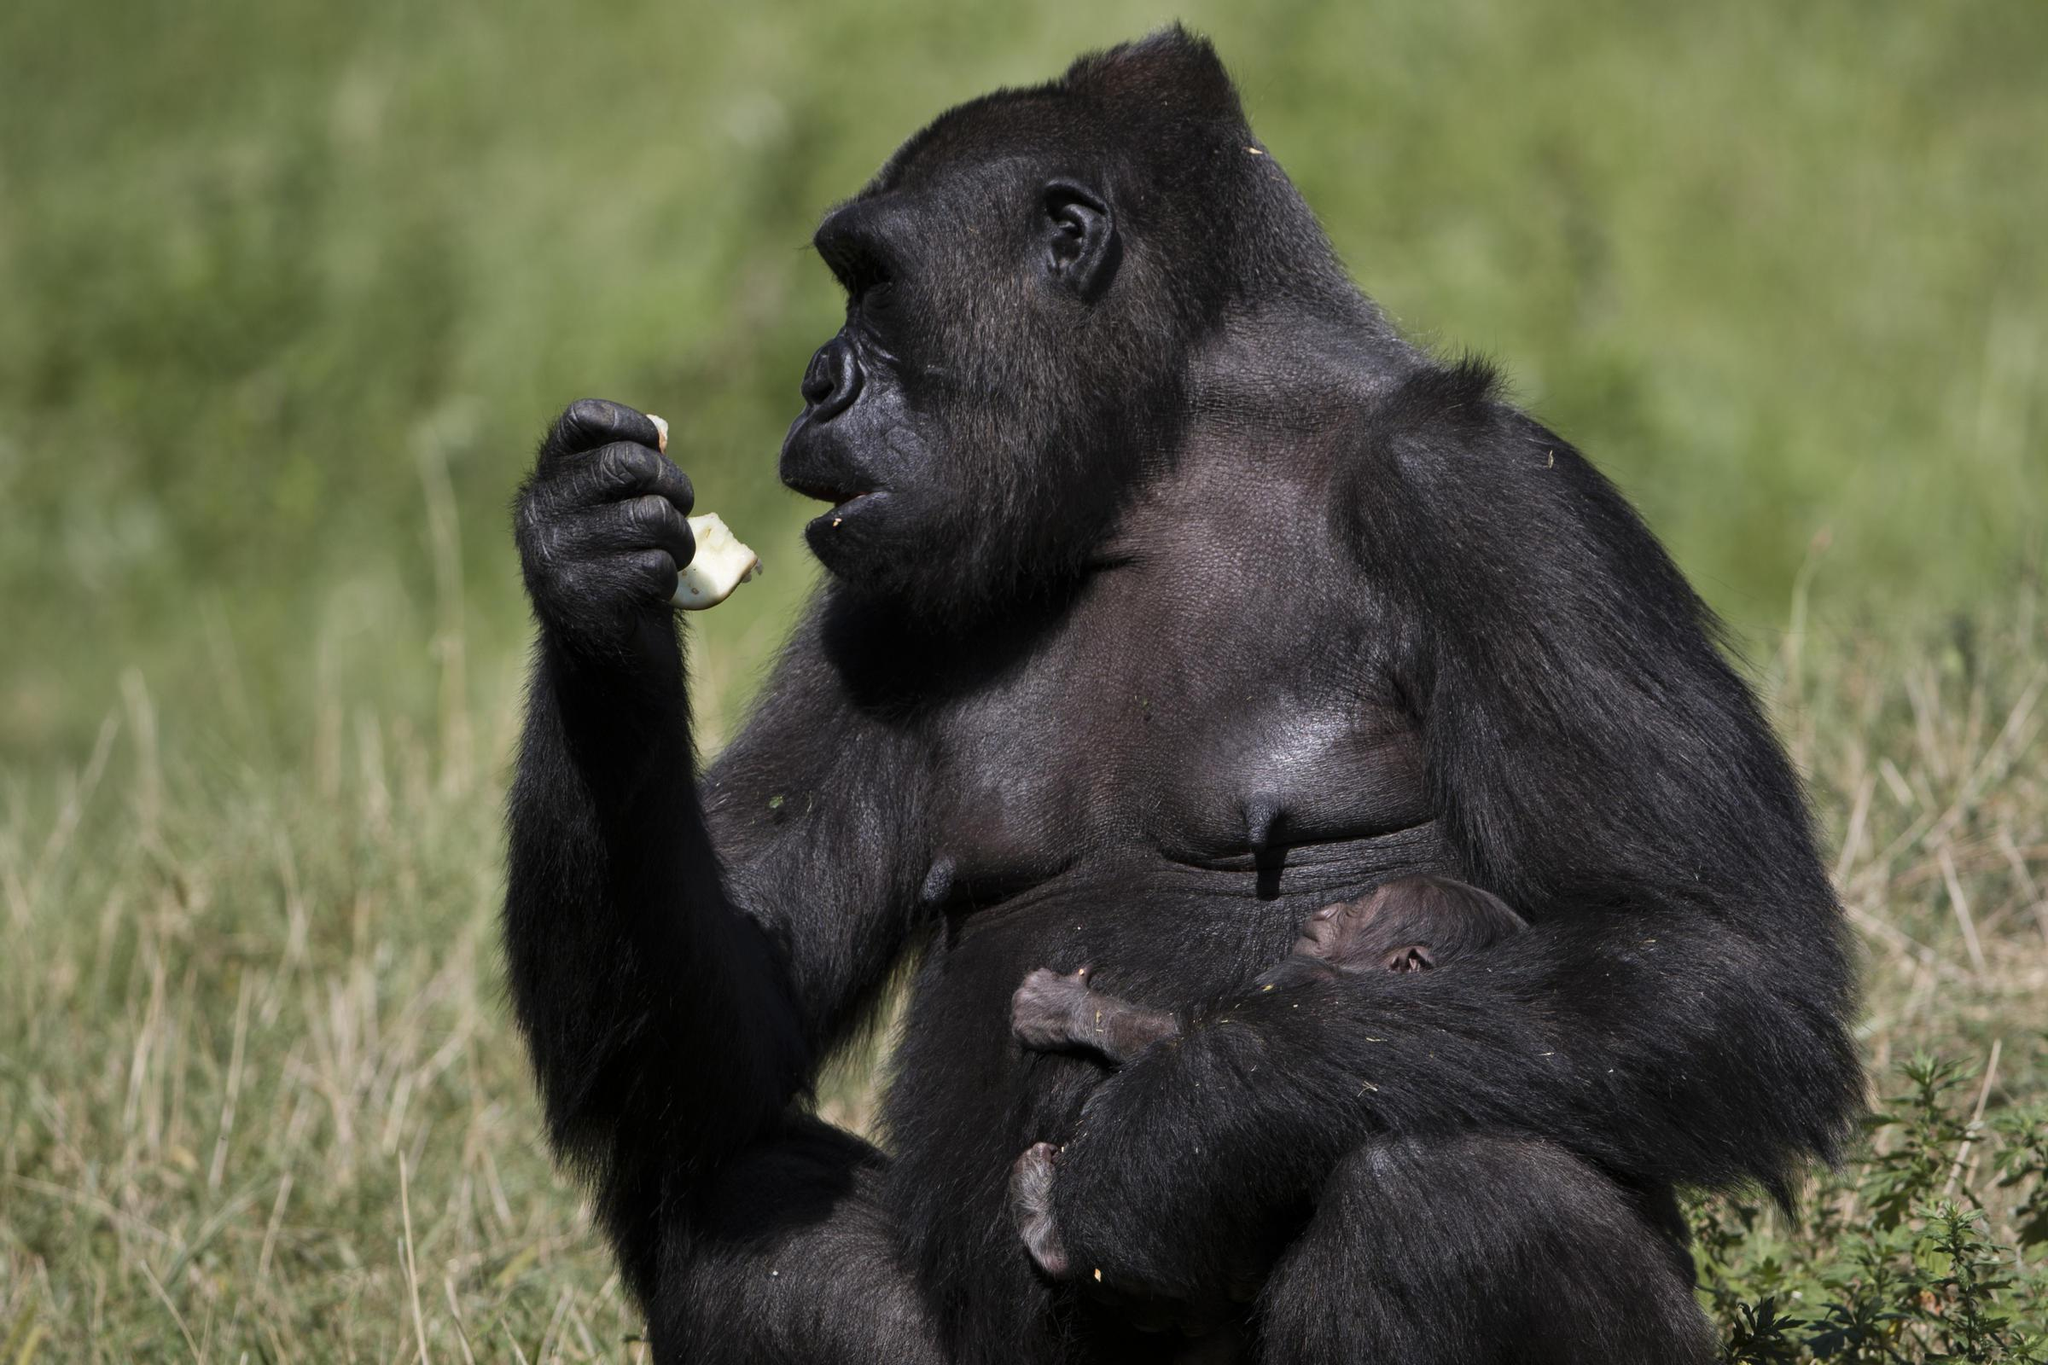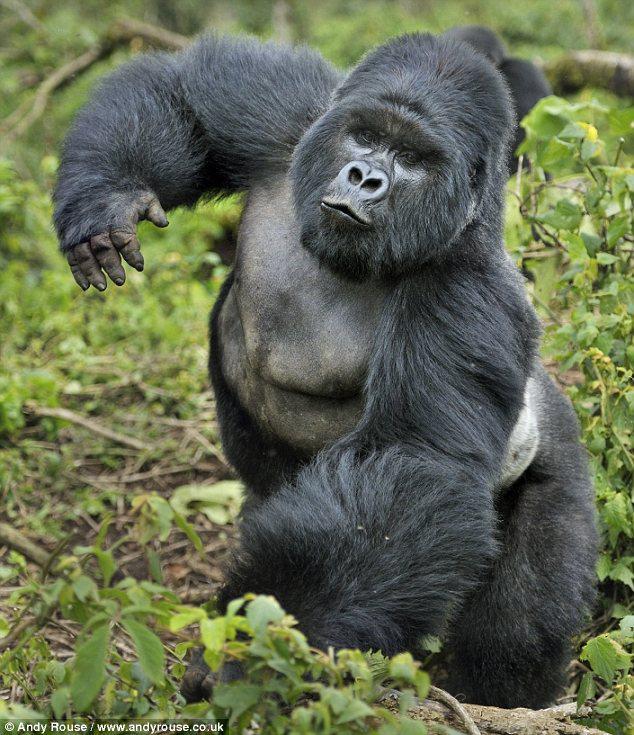The first image is the image on the left, the second image is the image on the right. Analyze the images presented: Is the assertion "One of the gorillas is touching its face with its left hand." valid? Answer yes or no. No. The first image is the image on the left, the second image is the image on the right. For the images displayed, is the sentence "Atleast one photo has a baby monkey looking to the right" factually correct? Answer yes or no. No. 